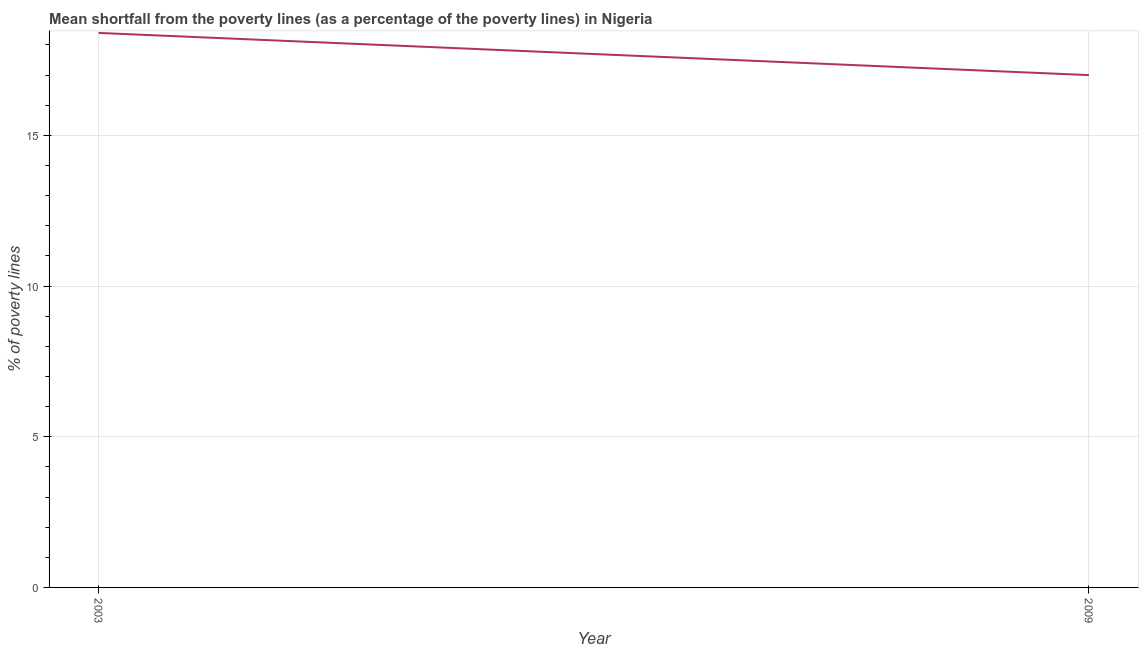Across all years, what is the minimum poverty gap at national poverty lines?
Make the answer very short. 17. In which year was the poverty gap at national poverty lines minimum?
Your response must be concise. 2009. What is the sum of the poverty gap at national poverty lines?
Your answer should be very brief. 35.4. What is the difference between the poverty gap at national poverty lines in 2003 and 2009?
Offer a terse response. 1.4. What is the median poverty gap at national poverty lines?
Offer a terse response. 17.7. In how many years, is the poverty gap at national poverty lines greater than 17 %?
Provide a short and direct response. 1. What is the ratio of the poverty gap at national poverty lines in 2003 to that in 2009?
Offer a very short reply. 1.08. Is the poverty gap at national poverty lines in 2003 less than that in 2009?
Your response must be concise. No. How many lines are there?
Provide a short and direct response. 1. How many years are there in the graph?
Provide a succinct answer. 2. What is the difference between two consecutive major ticks on the Y-axis?
Your answer should be compact. 5. Does the graph contain any zero values?
Offer a very short reply. No. Does the graph contain grids?
Your answer should be very brief. Yes. What is the title of the graph?
Make the answer very short. Mean shortfall from the poverty lines (as a percentage of the poverty lines) in Nigeria. What is the label or title of the X-axis?
Give a very brief answer. Year. What is the label or title of the Y-axis?
Offer a terse response. % of poverty lines. What is the % of poverty lines of 2009?
Give a very brief answer. 17. What is the difference between the % of poverty lines in 2003 and 2009?
Ensure brevity in your answer.  1.4. What is the ratio of the % of poverty lines in 2003 to that in 2009?
Give a very brief answer. 1.08. 